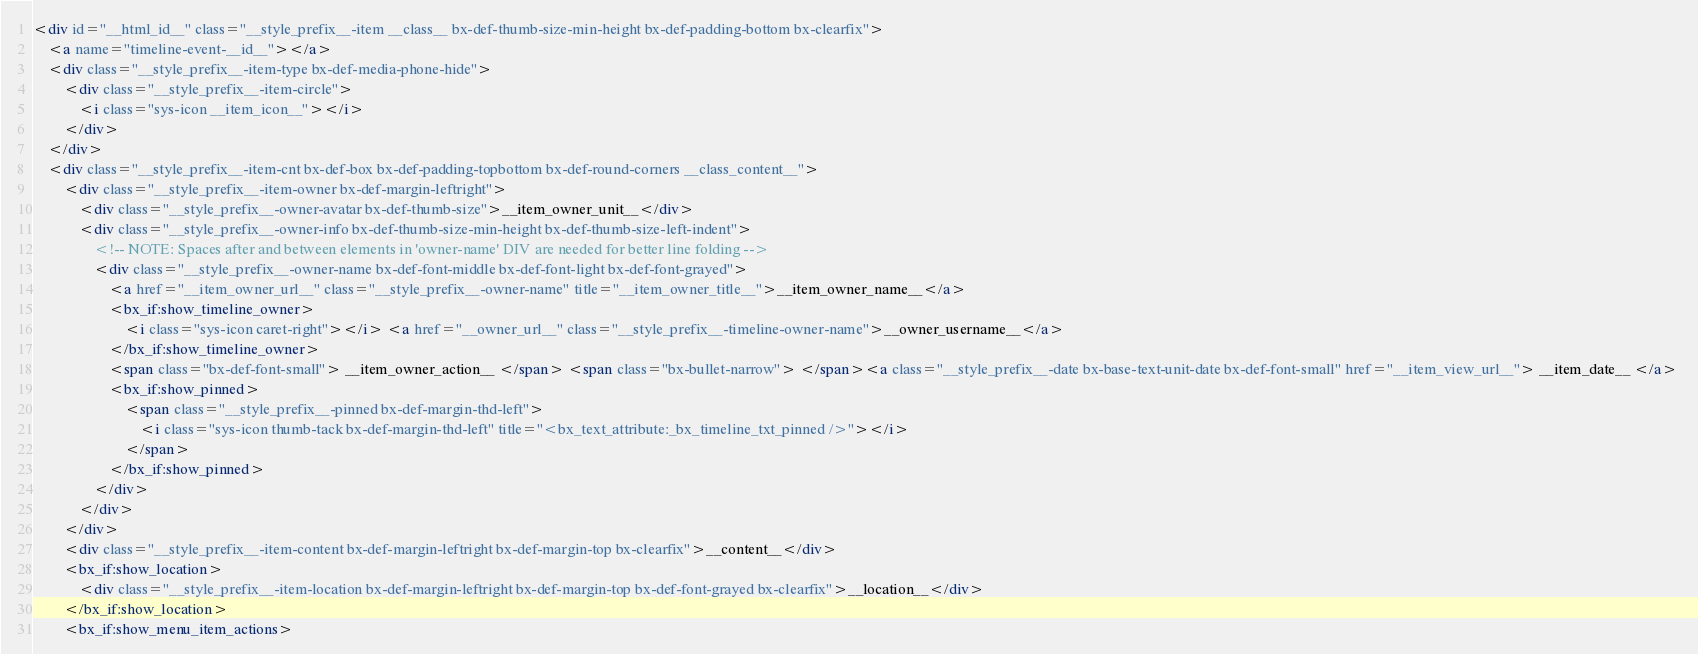<code> <loc_0><loc_0><loc_500><loc_500><_HTML_><div id="__html_id__" class="__style_prefix__-item __class__ bx-def-thumb-size-min-height bx-def-padding-bottom bx-clearfix">
    <a name="timeline-event-__id__"></a>
    <div class="__style_prefix__-item-type bx-def-media-phone-hide">
	    <div class="__style_prefix__-item-circle">
			<i class="sys-icon __item_icon__"></i>
        </div>
    </div>
    <div class="__style_prefix__-item-cnt bx-def-box bx-def-padding-topbottom bx-def-round-corners __class_content__">
        <div class="__style_prefix__-item-owner bx-def-margin-leftright"> 
            <div class="__style_prefix__-owner-avatar bx-def-thumb-size">__item_owner_unit__</div>
            <div class="__style_prefix__-owner-info bx-def-thumb-size-min-height bx-def-thumb-size-left-indent">
                <!-- NOTE: Spaces after and between elements in 'owner-name' DIV are needed for better line folding -->
                <div class="__style_prefix__-owner-name bx-def-font-middle bx-def-font-light bx-def-font-grayed">
                    <a href="__item_owner_url__" class="__style_prefix__-owner-name" title="__item_owner_title__">__item_owner_name__</a> 
                    <bx_if:show_timeline_owner>
                        <i class="sys-icon caret-right"></i> <a href="__owner_url__" class="__style_prefix__-timeline-owner-name">__owner_username__</a> 
                    </bx_if:show_timeline_owner>
                    <span class="bx-def-font-small"> __item_owner_action__ </span> <span class="bx-bullet-narrow"> </span><a class="__style_prefix__-date bx-base-text-unit-date bx-def-font-small" href="__item_view_url__"> __item_date__ </a> 
                    <bx_if:show_pinned>
                        <span class="__style_prefix__-pinned bx-def-margin-thd-left">
                            <i class="sys-icon thumb-tack bx-def-margin-thd-left" title="<bx_text_attribute:_bx_timeline_txt_pinned />"></i>
                        </span>
                    </bx_if:show_pinned>
                </div>
            </div>
        </div>
		<div class="__style_prefix__-item-content bx-def-margin-leftright bx-def-margin-top bx-clearfix">__content__</div>
		<bx_if:show_location>
		    <div class="__style_prefix__-item-location bx-def-margin-leftright bx-def-margin-top bx-def-font-grayed bx-clearfix">__location__</div>
		</bx_if:show_location>
		<bx_if:show_menu_item_actions></code> 